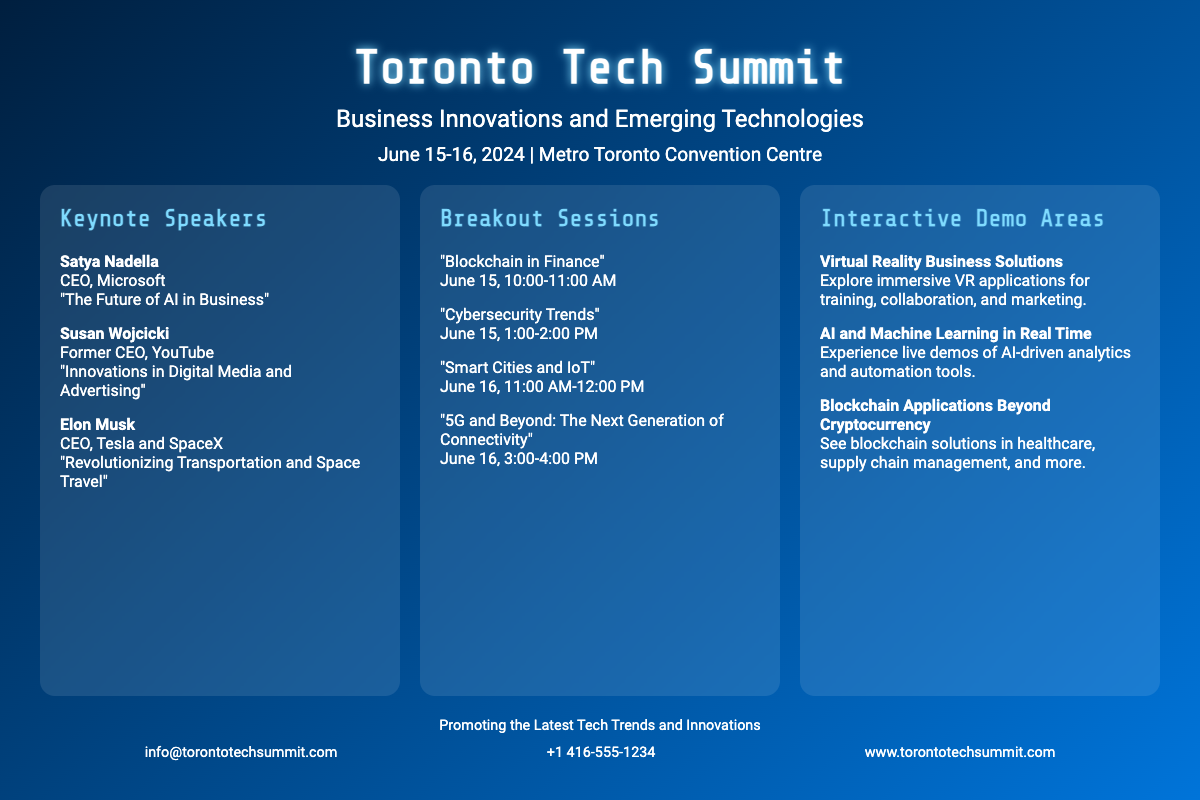What are the dates of the Toronto Tech Summit? The dates are explicitly mentioned in the document, which are June 15-16, 2024.
Answer: June 15-16, 2024 Who is the keynote speaker representing Microsoft? The speaker's name and title, along with their session topic, are included in the section about keynote speakers.
Answer: Satya Nadella When is the session on "Blockchain in Finance"? The specific date and time for this breakout session are outlined in the breakout sessions section.
Answer: June 15, 10:00-11:00 AM What is the title of Elon Musk's keynote session? This information can be found in the keynote speakers section along with the speaker's name and title.
Answer: Revolutionizing Transportation and Space Travel How many breakout sessions are listed? The document states the number of sessions in the breakout sessions section, which can easily be counted.
Answer: Four What is one of the interactive demo areas focusing on? The demonstration topics are detailed in the interactive demos section, providing specific examples.
Answer: Virtual Reality Business Solutions What is the venue for the Toronto Tech Summit? The location is clearly mentioned in the document near the event dates.
Answer: Metro Toronto Convention Centre Who is the former CEO of YouTube speaking at the summit? Information regarding the keynote speakers, including their previous titles, is provided in the relevant section.
Answer: Susan Wojcicki 